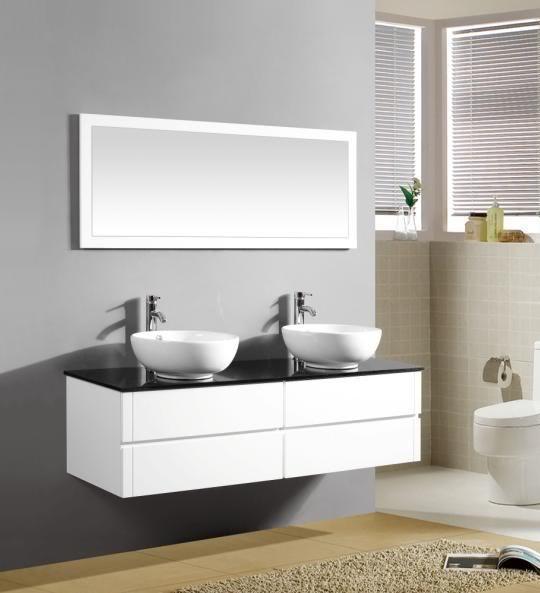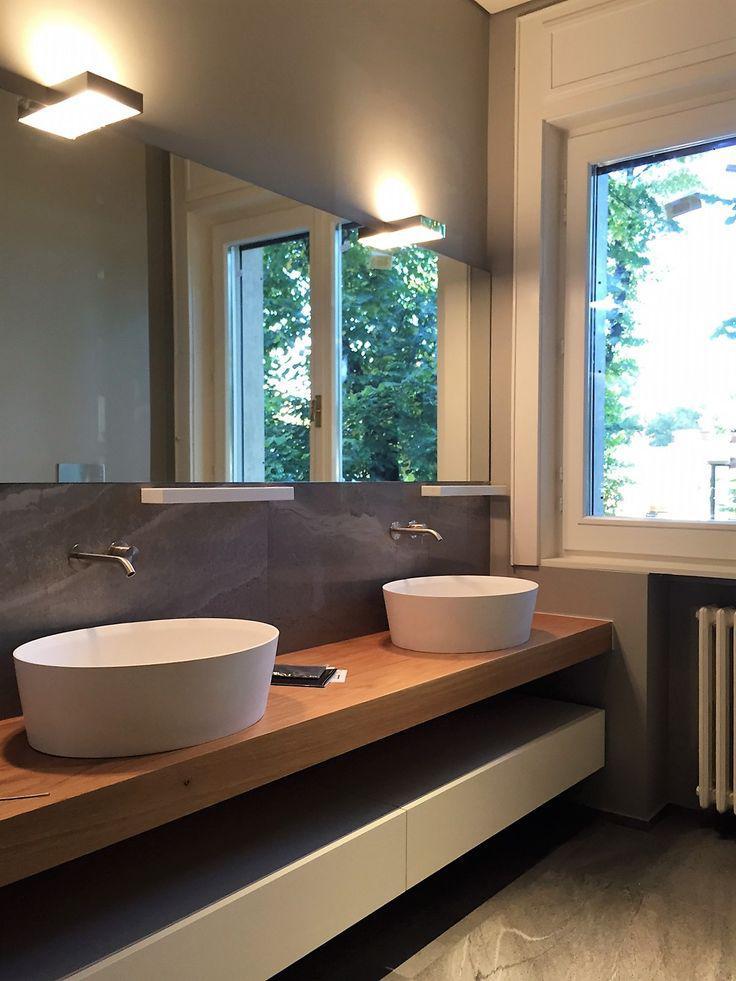The first image is the image on the left, the second image is the image on the right. Analyze the images presented: Is the assertion "An image shows a rectangular mirror above a rectangular double sinks on a white wall-mounted vanity, and one image features wall-mounted spouts above two sinks." valid? Answer yes or no. Yes. The first image is the image on the left, the second image is the image on the right. Given the left and right images, does the statement "At least one of the images has a window." hold true? Answer yes or no. Yes. 